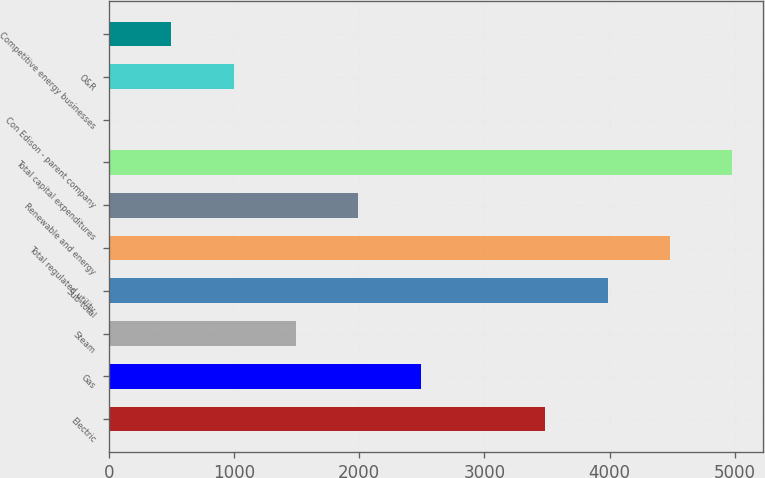<chart> <loc_0><loc_0><loc_500><loc_500><bar_chart><fcel>Electric<fcel>Gas<fcel>Steam<fcel>Sub-total<fcel>Total regulated utility<fcel>Renewable and energy<fcel>Total capital expenditures<fcel>Con Edison - parent company<fcel>O&R<fcel>Competitive energy businesses<nl><fcel>3486.6<fcel>2491<fcel>1495.4<fcel>3984.4<fcel>4482.2<fcel>1993.2<fcel>4980<fcel>2<fcel>997.6<fcel>499.8<nl></chart> 